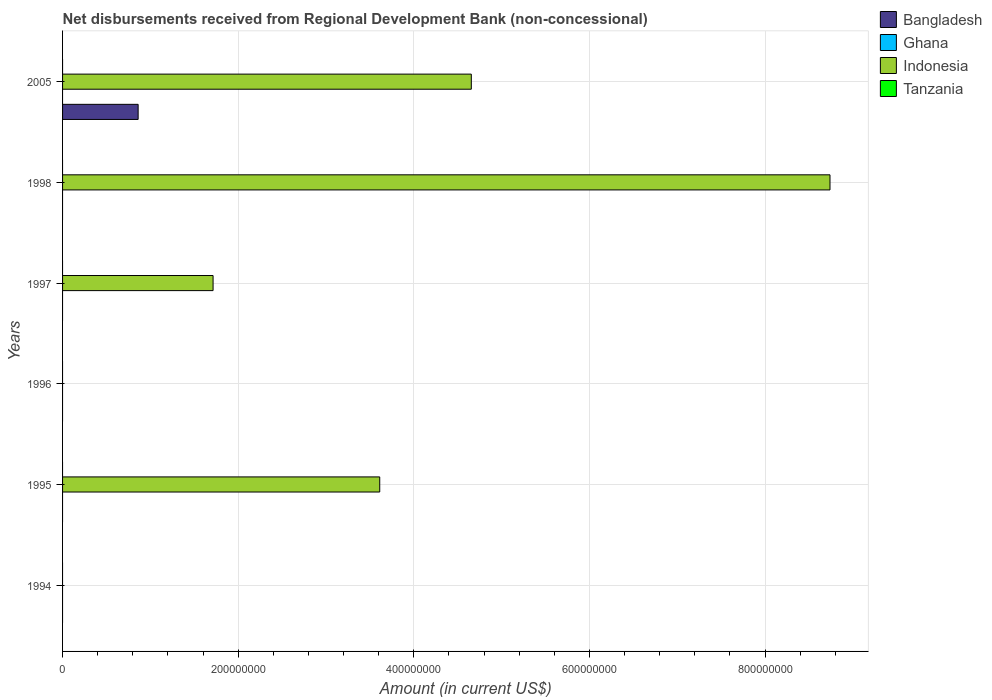How many bars are there on the 2nd tick from the top?
Your response must be concise. 1. How many bars are there on the 5th tick from the bottom?
Make the answer very short. 1. What is the label of the 4th group of bars from the top?
Keep it short and to the point. 1996. In how many cases, is the number of bars for a given year not equal to the number of legend labels?
Your answer should be compact. 6. What is the amount of disbursements received from Regional Development Bank in Indonesia in 1998?
Your response must be concise. 8.74e+08. Across all years, what is the maximum amount of disbursements received from Regional Development Bank in Indonesia?
Your answer should be compact. 8.74e+08. In which year was the amount of disbursements received from Regional Development Bank in Indonesia maximum?
Provide a succinct answer. 1998. What is the difference between the amount of disbursements received from Regional Development Bank in Indonesia in 1997 and that in 2005?
Provide a short and direct response. -2.94e+08. What is the average amount of disbursements received from Regional Development Bank in Tanzania per year?
Your response must be concise. 0. Is the amount of disbursements received from Regional Development Bank in Indonesia in 1997 less than that in 2005?
Offer a terse response. Yes. What is the difference between the highest and the second highest amount of disbursements received from Regional Development Bank in Indonesia?
Make the answer very short. 4.08e+08. What is the difference between the highest and the lowest amount of disbursements received from Regional Development Bank in Bangladesh?
Keep it short and to the point. 8.61e+07. Is it the case that in every year, the sum of the amount of disbursements received from Regional Development Bank in Ghana and amount of disbursements received from Regional Development Bank in Bangladesh is greater than the sum of amount of disbursements received from Regional Development Bank in Indonesia and amount of disbursements received from Regional Development Bank in Tanzania?
Provide a succinct answer. No. Are all the bars in the graph horizontal?
Your answer should be very brief. Yes. What is the difference between two consecutive major ticks on the X-axis?
Provide a short and direct response. 2.00e+08. Are the values on the major ticks of X-axis written in scientific E-notation?
Give a very brief answer. No. Does the graph contain grids?
Give a very brief answer. Yes. Where does the legend appear in the graph?
Ensure brevity in your answer.  Top right. How many legend labels are there?
Your response must be concise. 4. How are the legend labels stacked?
Ensure brevity in your answer.  Vertical. What is the title of the graph?
Provide a short and direct response. Net disbursements received from Regional Development Bank (non-concessional). Does "High income" appear as one of the legend labels in the graph?
Provide a succinct answer. No. What is the label or title of the Y-axis?
Make the answer very short. Years. What is the Amount (in current US$) of Indonesia in 1994?
Ensure brevity in your answer.  0. What is the Amount (in current US$) of Tanzania in 1994?
Your answer should be compact. 0. What is the Amount (in current US$) of Indonesia in 1995?
Your answer should be compact. 3.61e+08. What is the Amount (in current US$) of Tanzania in 1995?
Give a very brief answer. 0. What is the Amount (in current US$) in Bangladesh in 1996?
Give a very brief answer. 0. What is the Amount (in current US$) in Ghana in 1996?
Give a very brief answer. 0. What is the Amount (in current US$) in Indonesia in 1996?
Offer a terse response. 0. What is the Amount (in current US$) of Tanzania in 1996?
Offer a terse response. 0. What is the Amount (in current US$) in Bangladesh in 1997?
Give a very brief answer. 0. What is the Amount (in current US$) of Indonesia in 1997?
Provide a short and direct response. 1.71e+08. What is the Amount (in current US$) of Ghana in 1998?
Your answer should be compact. 0. What is the Amount (in current US$) of Indonesia in 1998?
Provide a short and direct response. 8.74e+08. What is the Amount (in current US$) of Bangladesh in 2005?
Your answer should be compact. 8.61e+07. What is the Amount (in current US$) in Indonesia in 2005?
Offer a very short reply. 4.65e+08. Across all years, what is the maximum Amount (in current US$) in Bangladesh?
Give a very brief answer. 8.61e+07. Across all years, what is the maximum Amount (in current US$) in Indonesia?
Your response must be concise. 8.74e+08. What is the total Amount (in current US$) of Bangladesh in the graph?
Provide a succinct answer. 8.61e+07. What is the total Amount (in current US$) in Indonesia in the graph?
Your response must be concise. 1.87e+09. What is the total Amount (in current US$) of Tanzania in the graph?
Keep it short and to the point. 0. What is the difference between the Amount (in current US$) in Indonesia in 1995 and that in 1997?
Your response must be concise. 1.90e+08. What is the difference between the Amount (in current US$) of Indonesia in 1995 and that in 1998?
Offer a terse response. -5.13e+08. What is the difference between the Amount (in current US$) of Indonesia in 1995 and that in 2005?
Offer a terse response. -1.04e+08. What is the difference between the Amount (in current US$) in Indonesia in 1997 and that in 1998?
Your response must be concise. -7.03e+08. What is the difference between the Amount (in current US$) of Indonesia in 1997 and that in 2005?
Offer a terse response. -2.94e+08. What is the difference between the Amount (in current US$) of Indonesia in 1998 and that in 2005?
Give a very brief answer. 4.08e+08. What is the average Amount (in current US$) of Bangladesh per year?
Make the answer very short. 1.43e+07. What is the average Amount (in current US$) of Indonesia per year?
Offer a terse response. 3.12e+08. In the year 2005, what is the difference between the Amount (in current US$) of Bangladesh and Amount (in current US$) of Indonesia?
Your answer should be very brief. -3.79e+08. What is the ratio of the Amount (in current US$) in Indonesia in 1995 to that in 1997?
Provide a short and direct response. 2.11. What is the ratio of the Amount (in current US$) of Indonesia in 1995 to that in 1998?
Your response must be concise. 0.41. What is the ratio of the Amount (in current US$) in Indonesia in 1995 to that in 2005?
Provide a short and direct response. 0.78. What is the ratio of the Amount (in current US$) of Indonesia in 1997 to that in 1998?
Offer a very short reply. 0.2. What is the ratio of the Amount (in current US$) in Indonesia in 1997 to that in 2005?
Offer a very short reply. 0.37. What is the ratio of the Amount (in current US$) in Indonesia in 1998 to that in 2005?
Ensure brevity in your answer.  1.88. What is the difference between the highest and the second highest Amount (in current US$) in Indonesia?
Your answer should be very brief. 4.08e+08. What is the difference between the highest and the lowest Amount (in current US$) in Bangladesh?
Provide a succinct answer. 8.61e+07. What is the difference between the highest and the lowest Amount (in current US$) of Indonesia?
Offer a terse response. 8.74e+08. 